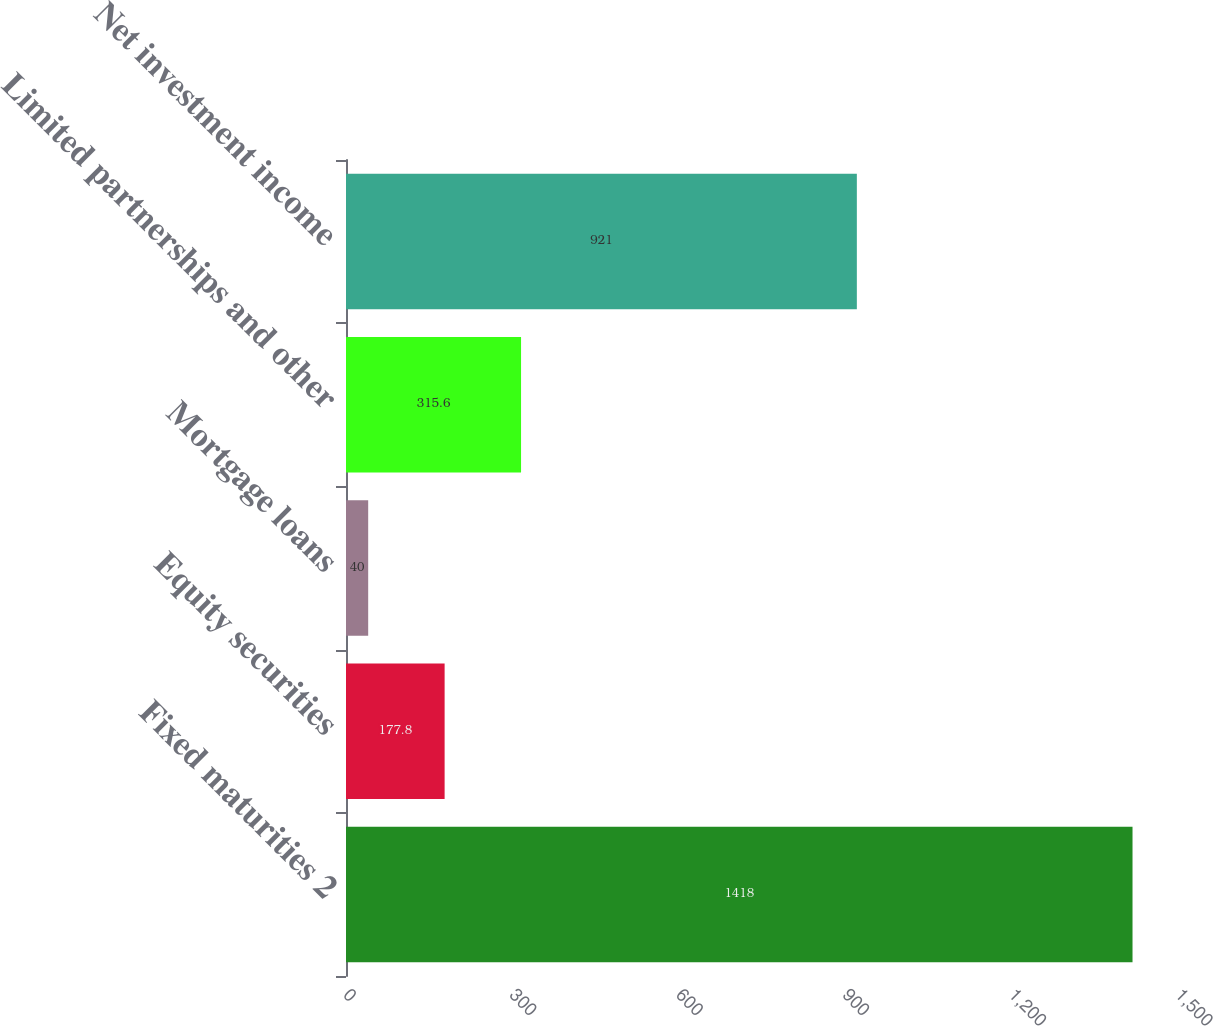Convert chart to OTSL. <chart><loc_0><loc_0><loc_500><loc_500><bar_chart><fcel>Fixed maturities 2<fcel>Equity securities<fcel>Mortgage loans<fcel>Limited partnerships and other<fcel>Net investment income<nl><fcel>1418<fcel>177.8<fcel>40<fcel>315.6<fcel>921<nl></chart> 